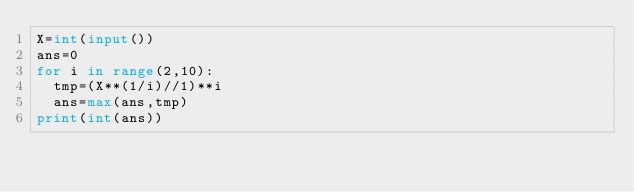Convert code to text. <code><loc_0><loc_0><loc_500><loc_500><_Python_>X=int(input())
ans=0
for i in range(2,10):
  tmp=(X**(1/i)//1)**i
  ans=max(ans,tmp)
print(int(ans))</code> 